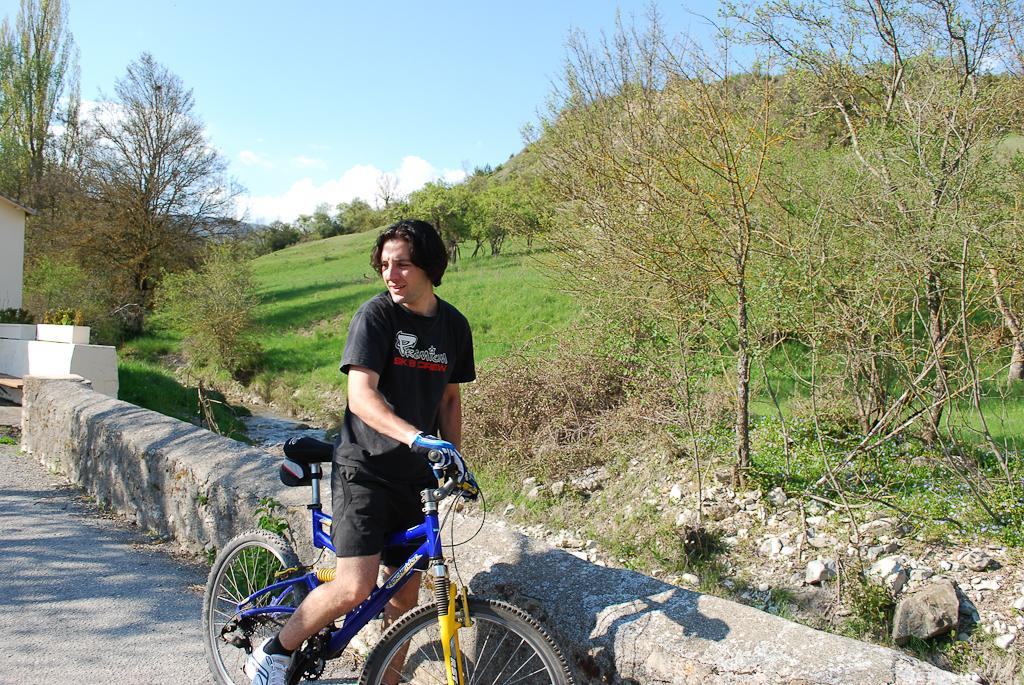Where was the image taken? The image is taken outdoors. What is the weather like in the image? It is sunny in the image. Can you describe the man in the image? The man is wearing a black t-shirt and holding a bicycle. What can be seen in the background of the image? There are trees, a sky with clouds, and a wall visible in the background of the image. What type of flower is growing on the line in the image? There is no flower or line present in the image. 